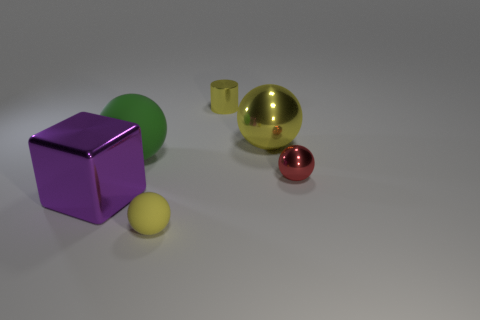What number of other things are there of the same color as the shiny cylinder?
Keep it short and to the point. 2. The green rubber ball is what size?
Ensure brevity in your answer.  Large. What number of blocks are either matte objects or large objects?
Make the answer very short. 1. The other sphere that is made of the same material as the big yellow sphere is what size?
Your answer should be compact. Small. What number of tiny metallic cylinders are the same color as the big metallic ball?
Give a very brief answer. 1. There is a tiny yellow sphere; are there any large yellow objects in front of it?
Give a very brief answer. No. Does the yellow matte object have the same shape as the small yellow object behind the large purple cube?
Offer a very short reply. No. How many objects are either metallic objects right of the large yellow metal thing or tiny cubes?
Ensure brevity in your answer.  1. Is there any other thing that has the same material as the large yellow sphere?
Give a very brief answer. Yes. How many metallic things are both in front of the big metal ball and right of the yellow rubber object?
Provide a succinct answer. 1. 